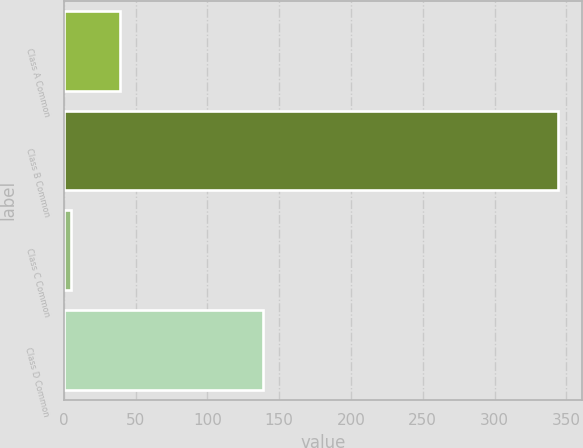<chart> <loc_0><loc_0><loc_500><loc_500><bar_chart><fcel>Class A Common<fcel>Class B Common<fcel>Class C Common<fcel>Class D Common<nl><fcel>38.9<fcel>344<fcel>5<fcel>139<nl></chart> 